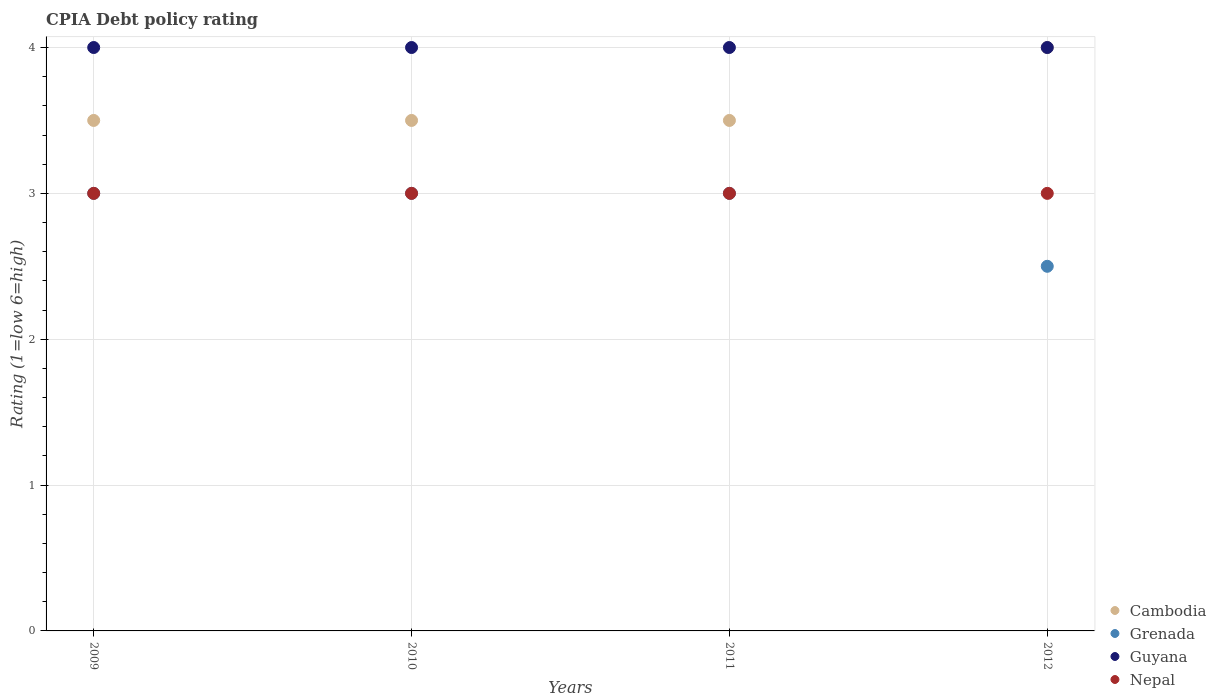How many different coloured dotlines are there?
Give a very brief answer. 4. Is the number of dotlines equal to the number of legend labels?
Offer a very short reply. Yes. In which year was the CPIA rating in Nepal minimum?
Make the answer very short. 2009. What is the total CPIA rating in Nepal in the graph?
Provide a short and direct response. 12. What is the difference between the CPIA rating in Guyana in 2010 and the CPIA rating in Nepal in 2009?
Your answer should be very brief. 1. What is the average CPIA rating in Grenada per year?
Give a very brief answer. 2.88. Is the CPIA rating in Grenada in 2010 less than that in 2011?
Your answer should be very brief. No. Is the sum of the CPIA rating in Cambodia in 2009 and 2010 greater than the maximum CPIA rating in Guyana across all years?
Make the answer very short. Yes. Is it the case that in every year, the sum of the CPIA rating in Guyana and CPIA rating in Grenada  is greater than the sum of CPIA rating in Nepal and CPIA rating in Cambodia?
Keep it short and to the point. No. Does the CPIA rating in Cambodia monotonically increase over the years?
Ensure brevity in your answer.  No. Is the CPIA rating in Grenada strictly less than the CPIA rating in Nepal over the years?
Your response must be concise. No. How many dotlines are there?
Make the answer very short. 4. How many years are there in the graph?
Your answer should be compact. 4. What is the difference between two consecutive major ticks on the Y-axis?
Offer a terse response. 1. Are the values on the major ticks of Y-axis written in scientific E-notation?
Offer a terse response. No. How many legend labels are there?
Give a very brief answer. 4. How are the legend labels stacked?
Your answer should be compact. Vertical. What is the title of the graph?
Keep it short and to the point. CPIA Debt policy rating. What is the label or title of the X-axis?
Offer a terse response. Years. What is the Rating (1=low 6=high) of Nepal in 2009?
Make the answer very short. 3. What is the Rating (1=low 6=high) of Grenada in 2010?
Provide a short and direct response. 3. What is the Rating (1=low 6=high) of Guyana in 2010?
Provide a succinct answer. 4. What is the Rating (1=low 6=high) of Nepal in 2010?
Offer a very short reply. 3. What is the Rating (1=low 6=high) in Guyana in 2011?
Give a very brief answer. 4. What is the Rating (1=low 6=high) of Nepal in 2011?
Your answer should be compact. 3. What is the Rating (1=low 6=high) of Grenada in 2012?
Keep it short and to the point. 2.5. What is the Rating (1=low 6=high) of Guyana in 2012?
Your answer should be compact. 4. Across all years, what is the maximum Rating (1=low 6=high) of Grenada?
Your answer should be compact. 3. Across all years, what is the maximum Rating (1=low 6=high) of Guyana?
Your answer should be compact. 4. Across all years, what is the maximum Rating (1=low 6=high) of Nepal?
Provide a succinct answer. 3. Across all years, what is the minimum Rating (1=low 6=high) in Cambodia?
Give a very brief answer. 3.5. What is the total Rating (1=low 6=high) in Grenada in the graph?
Offer a terse response. 11.5. What is the total Rating (1=low 6=high) of Guyana in the graph?
Offer a terse response. 16. What is the total Rating (1=low 6=high) in Nepal in the graph?
Offer a very short reply. 12. What is the difference between the Rating (1=low 6=high) of Cambodia in 2009 and that in 2010?
Offer a very short reply. 0. What is the difference between the Rating (1=low 6=high) in Grenada in 2009 and that in 2010?
Ensure brevity in your answer.  0. What is the difference between the Rating (1=low 6=high) of Grenada in 2009 and that in 2011?
Offer a terse response. 0. What is the difference between the Rating (1=low 6=high) in Grenada in 2009 and that in 2012?
Make the answer very short. 0.5. What is the difference between the Rating (1=low 6=high) in Grenada in 2010 and that in 2011?
Your answer should be very brief. 0. What is the difference between the Rating (1=low 6=high) of Guyana in 2010 and that in 2011?
Keep it short and to the point. 0. What is the difference between the Rating (1=low 6=high) in Nepal in 2010 and that in 2011?
Your answer should be very brief. 0. What is the difference between the Rating (1=low 6=high) in Grenada in 2010 and that in 2012?
Provide a short and direct response. 0.5. What is the difference between the Rating (1=low 6=high) of Guyana in 2010 and that in 2012?
Make the answer very short. 0. What is the difference between the Rating (1=low 6=high) in Grenada in 2011 and that in 2012?
Provide a short and direct response. 0.5. What is the difference between the Rating (1=low 6=high) of Cambodia in 2009 and the Rating (1=low 6=high) of Nepal in 2010?
Offer a very short reply. 0.5. What is the difference between the Rating (1=low 6=high) of Grenada in 2009 and the Rating (1=low 6=high) of Guyana in 2010?
Offer a terse response. -1. What is the difference between the Rating (1=low 6=high) of Grenada in 2009 and the Rating (1=low 6=high) of Nepal in 2010?
Offer a terse response. 0. What is the difference between the Rating (1=low 6=high) of Guyana in 2009 and the Rating (1=low 6=high) of Nepal in 2010?
Make the answer very short. 1. What is the difference between the Rating (1=low 6=high) in Cambodia in 2009 and the Rating (1=low 6=high) in Grenada in 2011?
Offer a very short reply. 0.5. What is the difference between the Rating (1=low 6=high) of Cambodia in 2009 and the Rating (1=low 6=high) of Guyana in 2011?
Make the answer very short. -0.5. What is the difference between the Rating (1=low 6=high) of Grenada in 2009 and the Rating (1=low 6=high) of Guyana in 2011?
Ensure brevity in your answer.  -1. What is the difference between the Rating (1=low 6=high) of Guyana in 2009 and the Rating (1=low 6=high) of Nepal in 2011?
Provide a short and direct response. 1. What is the difference between the Rating (1=low 6=high) of Cambodia in 2009 and the Rating (1=low 6=high) of Nepal in 2012?
Provide a succinct answer. 0.5. What is the difference between the Rating (1=low 6=high) in Grenada in 2009 and the Rating (1=low 6=high) in Guyana in 2012?
Offer a terse response. -1. What is the difference between the Rating (1=low 6=high) in Grenada in 2009 and the Rating (1=low 6=high) in Nepal in 2012?
Provide a short and direct response. 0. What is the difference between the Rating (1=low 6=high) in Guyana in 2009 and the Rating (1=low 6=high) in Nepal in 2012?
Your answer should be very brief. 1. What is the difference between the Rating (1=low 6=high) of Cambodia in 2010 and the Rating (1=low 6=high) of Guyana in 2011?
Offer a very short reply. -0.5. What is the difference between the Rating (1=low 6=high) in Cambodia in 2010 and the Rating (1=low 6=high) in Nepal in 2011?
Offer a very short reply. 0.5. What is the difference between the Rating (1=low 6=high) of Grenada in 2010 and the Rating (1=low 6=high) of Guyana in 2011?
Ensure brevity in your answer.  -1. What is the difference between the Rating (1=low 6=high) of Grenada in 2010 and the Rating (1=low 6=high) of Nepal in 2011?
Offer a very short reply. 0. What is the difference between the Rating (1=low 6=high) in Cambodia in 2010 and the Rating (1=low 6=high) in Grenada in 2012?
Provide a short and direct response. 1. What is the difference between the Rating (1=low 6=high) in Cambodia in 2010 and the Rating (1=low 6=high) in Nepal in 2012?
Your answer should be very brief. 0.5. What is the difference between the Rating (1=low 6=high) in Grenada in 2010 and the Rating (1=low 6=high) in Guyana in 2012?
Provide a succinct answer. -1. What is the difference between the Rating (1=low 6=high) of Grenada in 2010 and the Rating (1=low 6=high) of Nepal in 2012?
Your answer should be very brief. 0. What is the difference between the Rating (1=low 6=high) in Cambodia in 2011 and the Rating (1=low 6=high) in Nepal in 2012?
Your answer should be compact. 0.5. What is the average Rating (1=low 6=high) of Cambodia per year?
Give a very brief answer. 3.62. What is the average Rating (1=low 6=high) in Grenada per year?
Keep it short and to the point. 2.88. What is the average Rating (1=low 6=high) of Nepal per year?
Give a very brief answer. 3. In the year 2009, what is the difference between the Rating (1=low 6=high) in Guyana and Rating (1=low 6=high) in Nepal?
Offer a very short reply. 1. In the year 2010, what is the difference between the Rating (1=low 6=high) in Grenada and Rating (1=low 6=high) in Nepal?
Offer a very short reply. 0. In the year 2010, what is the difference between the Rating (1=low 6=high) in Guyana and Rating (1=low 6=high) in Nepal?
Your answer should be very brief. 1. In the year 2011, what is the difference between the Rating (1=low 6=high) in Cambodia and Rating (1=low 6=high) in Guyana?
Your response must be concise. -0.5. In the year 2011, what is the difference between the Rating (1=low 6=high) of Cambodia and Rating (1=low 6=high) of Nepal?
Make the answer very short. 0.5. In the year 2012, what is the difference between the Rating (1=low 6=high) of Cambodia and Rating (1=low 6=high) of Guyana?
Your response must be concise. 0. In the year 2012, what is the difference between the Rating (1=low 6=high) of Grenada and Rating (1=low 6=high) of Guyana?
Your answer should be very brief. -1.5. In the year 2012, what is the difference between the Rating (1=low 6=high) of Grenada and Rating (1=low 6=high) of Nepal?
Your response must be concise. -0.5. In the year 2012, what is the difference between the Rating (1=low 6=high) in Guyana and Rating (1=low 6=high) in Nepal?
Provide a short and direct response. 1. What is the ratio of the Rating (1=low 6=high) in Cambodia in 2009 to that in 2010?
Your response must be concise. 1. What is the ratio of the Rating (1=low 6=high) of Grenada in 2009 to that in 2010?
Ensure brevity in your answer.  1. What is the ratio of the Rating (1=low 6=high) in Guyana in 2009 to that in 2010?
Ensure brevity in your answer.  1. What is the ratio of the Rating (1=low 6=high) of Nepal in 2009 to that in 2010?
Give a very brief answer. 1. What is the ratio of the Rating (1=low 6=high) in Grenada in 2009 to that in 2011?
Give a very brief answer. 1. What is the ratio of the Rating (1=low 6=high) of Nepal in 2009 to that in 2011?
Ensure brevity in your answer.  1. What is the ratio of the Rating (1=low 6=high) in Grenada in 2009 to that in 2012?
Ensure brevity in your answer.  1.2. What is the ratio of the Rating (1=low 6=high) of Nepal in 2009 to that in 2012?
Your answer should be compact. 1. What is the ratio of the Rating (1=low 6=high) of Cambodia in 2010 to that in 2011?
Make the answer very short. 1. What is the ratio of the Rating (1=low 6=high) in Guyana in 2010 to that in 2011?
Ensure brevity in your answer.  1. What is the ratio of the Rating (1=low 6=high) of Cambodia in 2010 to that in 2012?
Your answer should be compact. 0.88. What is the ratio of the Rating (1=low 6=high) in Grenada in 2010 to that in 2012?
Give a very brief answer. 1.2. What is the ratio of the Rating (1=low 6=high) in Guyana in 2011 to that in 2012?
Make the answer very short. 1. What is the difference between the highest and the second highest Rating (1=low 6=high) of Grenada?
Offer a terse response. 0. What is the difference between the highest and the second highest Rating (1=low 6=high) of Guyana?
Provide a succinct answer. 0. What is the difference between the highest and the lowest Rating (1=low 6=high) of Guyana?
Provide a succinct answer. 0. 